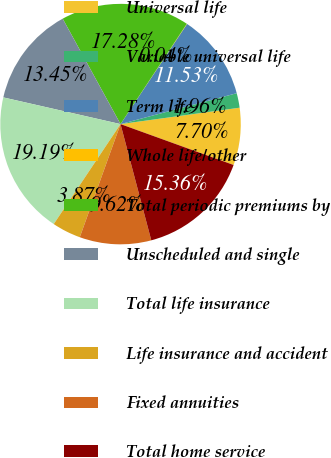Convert chart to OTSL. <chart><loc_0><loc_0><loc_500><loc_500><pie_chart><fcel>Universal life<fcel>Variable universal life<fcel>Term life<fcel>Whole life/other<fcel>Total periodic premiums by<fcel>Unscheduled and single<fcel>Total life insurance<fcel>Life insurance and accident<fcel>Fixed annuities<fcel>Total home service<nl><fcel>7.7%<fcel>1.96%<fcel>11.53%<fcel>0.04%<fcel>17.28%<fcel>13.45%<fcel>19.19%<fcel>3.87%<fcel>9.62%<fcel>15.36%<nl></chart> 